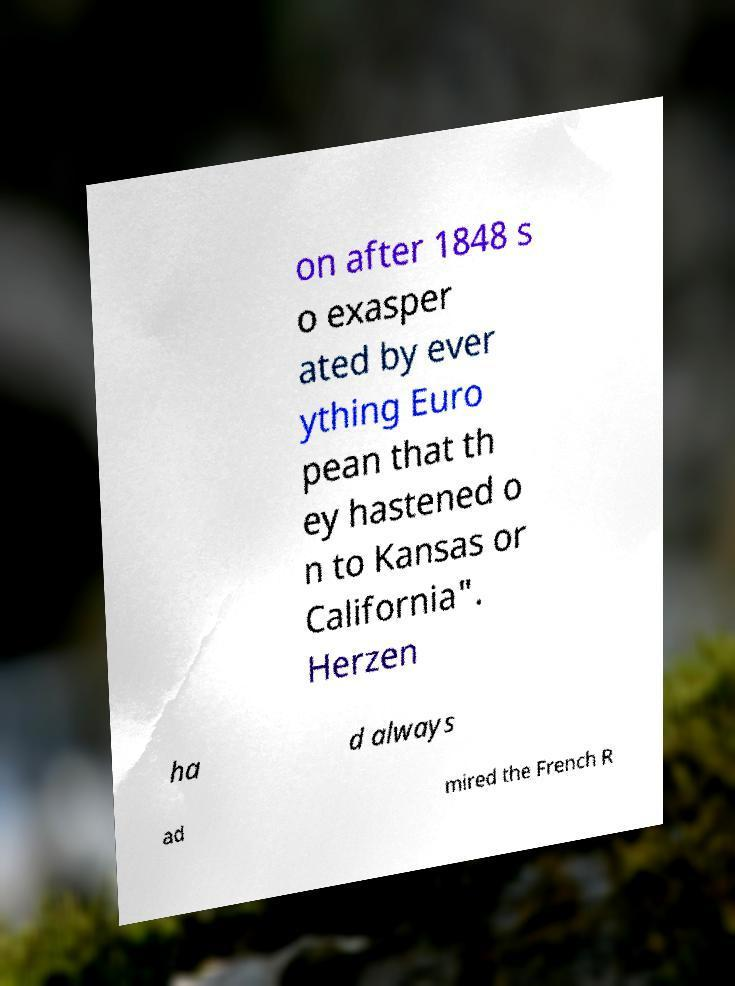I need the written content from this picture converted into text. Can you do that? on after 1848 s o exasper ated by ever ything Euro pean that th ey hastened o n to Kansas or California". Herzen ha d always ad mired the French R 